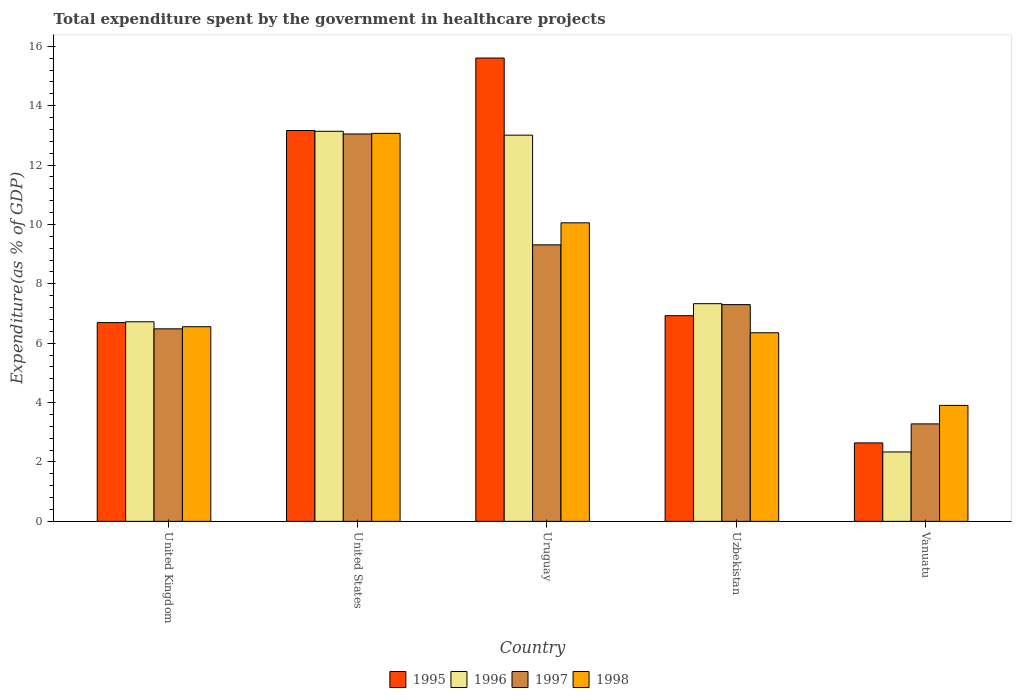How many different coloured bars are there?
Give a very brief answer. 4. How many groups of bars are there?
Give a very brief answer. 5. Are the number of bars on each tick of the X-axis equal?
Your answer should be compact. Yes. How many bars are there on the 5th tick from the left?
Offer a very short reply. 4. How many bars are there on the 2nd tick from the right?
Keep it short and to the point. 4. What is the label of the 1st group of bars from the left?
Offer a very short reply. United Kingdom. In how many cases, is the number of bars for a given country not equal to the number of legend labels?
Your answer should be compact. 0. What is the total expenditure spent by the government in healthcare projects in 1998 in Vanuatu?
Provide a short and direct response. 3.91. Across all countries, what is the maximum total expenditure spent by the government in healthcare projects in 1995?
Offer a very short reply. 15.6. Across all countries, what is the minimum total expenditure spent by the government in healthcare projects in 1998?
Your answer should be compact. 3.91. In which country was the total expenditure spent by the government in healthcare projects in 1996 minimum?
Offer a very short reply. Vanuatu. What is the total total expenditure spent by the government in healthcare projects in 1998 in the graph?
Provide a short and direct response. 39.93. What is the difference between the total expenditure spent by the government in healthcare projects in 1996 in Uruguay and that in Uzbekistan?
Provide a short and direct response. 5.68. What is the difference between the total expenditure spent by the government in healthcare projects in 1997 in Vanuatu and the total expenditure spent by the government in healthcare projects in 1995 in Uzbekistan?
Your answer should be very brief. -3.64. What is the average total expenditure spent by the government in healthcare projects in 1997 per country?
Your answer should be compact. 7.88. What is the difference between the total expenditure spent by the government in healthcare projects of/in 1997 and total expenditure spent by the government in healthcare projects of/in 1996 in Vanuatu?
Offer a very short reply. 0.95. What is the ratio of the total expenditure spent by the government in healthcare projects in 1997 in United States to that in Uzbekistan?
Your response must be concise. 1.79. What is the difference between the highest and the second highest total expenditure spent by the government in healthcare projects in 1996?
Give a very brief answer. -0.13. What is the difference between the highest and the lowest total expenditure spent by the government in healthcare projects in 1997?
Provide a succinct answer. 9.76. In how many countries, is the total expenditure spent by the government in healthcare projects in 1995 greater than the average total expenditure spent by the government in healthcare projects in 1995 taken over all countries?
Offer a terse response. 2. Is the sum of the total expenditure spent by the government in healthcare projects in 1997 in United States and Vanuatu greater than the maximum total expenditure spent by the government in healthcare projects in 1995 across all countries?
Ensure brevity in your answer.  Yes. What does the 3rd bar from the left in United Kingdom represents?
Offer a terse response. 1997. Is it the case that in every country, the sum of the total expenditure spent by the government in healthcare projects in 1998 and total expenditure spent by the government in healthcare projects in 1995 is greater than the total expenditure spent by the government in healthcare projects in 1997?
Your answer should be compact. Yes. How many bars are there?
Give a very brief answer. 20. Are all the bars in the graph horizontal?
Keep it short and to the point. No. What is the difference between two consecutive major ticks on the Y-axis?
Give a very brief answer. 2. Are the values on the major ticks of Y-axis written in scientific E-notation?
Offer a terse response. No. Does the graph contain any zero values?
Ensure brevity in your answer.  No. Does the graph contain grids?
Give a very brief answer. No. Where does the legend appear in the graph?
Make the answer very short. Bottom center. What is the title of the graph?
Offer a terse response. Total expenditure spent by the government in healthcare projects. What is the label or title of the X-axis?
Make the answer very short. Country. What is the label or title of the Y-axis?
Your answer should be compact. Expenditure(as % of GDP). What is the Expenditure(as % of GDP) in 1995 in United Kingdom?
Your answer should be very brief. 6.69. What is the Expenditure(as % of GDP) in 1996 in United Kingdom?
Keep it short and to the point. 6.72. What is the Expenditure(as % of GDP) of 1997 in United Kingdom?
Make the answer very short. 6.48. What is the Expenditure(as % of GDP) in 1998 in United Kingdom?
Ensure brevity in your answer.  6.56. What is the Expenditure(as % of GDP) in 1995 in United States?
Your answer should be very brief. 13.16. What is the Expenditure(as % of GDP) of 1996 in United States?
Ensure brevity in your answer.  13.14. What is the Expenditure(as % of GDP) in 1997 in United States?
Your response must be concise. 13.05. What is the Expenditure(as % of GDP) of 1998 in United States?
Provide a short and direct response. 13.07. What is the Expenditure(as % of GDP) in 1995 in Uruguay?
Make the answer very short. 15.6. What is the Expenditure(as % of GDP) of 1996 in Uruguay?
Your answer should be very brief. 13.01. What is the Expenditure(as % of GDP) in 1997 in Uruguay?
Make the answer very short. 9.31. What is the Expenditure(as % of GDP) of 1998 in Uruguay?
Offer a very short reply. 10.05. What is the Expenditure(as % of GDP) in 1995 in Uzbekistan?
Provide a short and direct response. 6.93. What is the Expenditure(as % of GDP) of 1996 in Uzbekistan?
Provide a succinct answer. 7.33. What is the Expenditure(as % of GDP) in 1997 in Uzbekistan?
Offer a very short reply. 7.3. What is the Expenditure(as % of GDP) of 1998 in Uzbekistan?
Keep it short and to the point. 6.35. What is the Expenditure(as % of GDP) in 1995 in Vanuatu?
Provide a short and direct response. 2.64. What is the Expenditure(as % of GDP) of 1996 in Vanuatu?
Make the answer very short. 2.34. What is the Expenditure(as % of GDP) of 1997 in Vanuatu?
Your answer should be compact. 3.28. What is the Expenditure(as % of GDP) of 1998 in Vanuatu?
Give a very brief answer. 3.91. Across all countries, what is the maximum Expenditure(as % of GDP) in 1995?
Keep it short and to the point. 15.6. Across all countries, what is the maximum Expenditure(as % of GDP) in 1996?
Provide a succinct answer. 13.14. Across all countries, what is the maximum Expenditure(as % of GDP) of 1997?
Give a very brief answer. 13.05. Across all countries, what is the maximum Expenditure(as % of GDP) of 1998?
Ensure brevity in your answer.  13.07. Across all countries, what is the minimum Expenditure(as % of GDP) of 1995?
Your answer should be very brief. 2.64. Across all countries, what is the minimum Expenditure(as % of GDP) in 1996?
Ensure brevity in your answer.  2.34. Across all countries, what is the minimum Expenditure(as % of GDP) of 1997?
Offer a very short reply. 3.28. Across all countries, what is the minimum Expenditure(as % of GDP) in 1998?
Provide a succinct answer. 3.91. What is the total Expenditure(as % of GDP) in 1995 in the graph?
Make the answer very short. 45.03. What is the total Expenditure(as % of GDP) in 1996 in the graph?
Your answer should be very brief. 42.53. What is the total Expenditure(as % of GDP) of 1997 in the graph?
Keep it short and to the point. 39.42. What is the total Expenditure(as % of GDP) of 1998 in the graph?
Provide a short and direct response. 39.93. What is the difference between the Expenditure(as % of GDP) of 1995 in United Kingdom and that in United States?
Provide a succinct answer. -6.47. What is the difference between the Expenditure(as % of GDP) in 1996 in United Kingdom and that in United States?
Offer a terse response. -6.41. What is the difference between the Expenditure(as % of GDP) in 1997 in United Kingdom and that in United States?
Keep it short and to the point. -6.56. What is the difference between the Expenditure(as % of GDP) of 1998 in United Kingdom and that in United States?
Ensure brevity in your answer.  -6.51. What is the difference between the Expenditure(as % of GDP) in 1995 in United Kingdom and that in Uruguay?
Offer a terse response. -8.91. What is the difference between the Expenditure(as % of GDP) in 1996 in United Kingdom and that in Uruguay?
Keep it short and to the point. -6.28. What is the difference between the Expenditure(as % of GDP) of 1997 in United Kingdom and that in Uruguay?
Provide a succinct answer. -2.83. What is the difference between the Expenditure(as % of GDP) of 1998 in United Kingdom and that in Uruguay?
Provide a short and direct response. -3.5. What is the difference between the Expenditure(as % of GDP) in 1995 in United Kingdom and that in Uzbekistan?
Ensure brevity in your answer.  -0.23. What is the difference between the Expenditure(as % of GDP) in 1996 in United Kingdom and that in Uzbekistan?
Offer a terse response. -0.61. What is the difference between the Expenditure(as % of GDP) in 1997 in United Kingdom and that in Uzbekistan?
Make the answer very short. -0.81. What is the difference between the Expenditure(as % of GDP) of 1998 in United Kingdom and that in Uzbekistan?
Provide a short and direct response. 0.2. What is the difference between the Expenditure(as % of GDP) of 1995 in United Kingdom and that in Vanuatu?
Make the answer very short. 4.05. What is the difference between the Expenditure(as % of GDP) in 1996 in United Kingdom and that in Vanuatu?
Your answer should be very brief. 4.38. What is the difference between the Expenditure(as % of GDP) in 1997 in United Kingdom and that in Vanuatu?
Offer a terse response. 3.2. What is the difference between the Expenditure(as % of GDP) of 1998 in United Kingdom and that in Vanuatu?
Keep it short and to the point. 2.65. What is the difference between the Expenditure(as % of GDP) of 1995 in United States and that in Uruguay?
Provide a succinct answer. -2.44. What is the difference between the Expenditure(as % of GDP) in 1996 in United States and that in Uruguay?
Make the answer very short. 0.13. What is the difference between the Expenditure(as % of GDP) of 1997 in United States and that in Uruguay?
Your answer should be compact. 3.73. What is the difference between the Expenditure(as % of GDP) of 1998 in United States and that in Uruguay?
Give a very brief answer. 3.01. What is the difference between the Expenditure(as % of GDP) of 1995 in United States and that in Uzbekistan?
Keep it short and to the point. 6.24. What is the difference between the Expenditure(as % of GDP) of 1996 in United States and that in Uzbekistan?
Give a very brief answer. 5.81. What is the difference between the Expenditure(as % of GDP) in 1997 in United States and that in Uzbekistan?
Offer a terse response. 5.75. What is the difference between the Expenditure(as % of GDP) in 1998 in United States and that in Uzbekistan?
Keep it short and to the point. 6.72. What is the difference between the Expenditure(as % of GDP) of 1995 in United States and that in Vanuatu?
Your response must be concise. 10.52. What is the difference between the Expenditure(as % of GDP) in 1996 in United States and that in Vanuatu?
Ensure brevity in your answer.  10.8. What is the difference between the Expenditure(as % of GDP) of 1997 in United States and that in Vanuatu?
Provide a short and direct response. 9.76. What is the difference between the Expenditure(as % of GDP) in 1998 in United States and that in Vanuatu?
Provide a short and direct response. 9.16. What is the difference between the Expenditure(as % of GDP) of 1995 in Uruguay and that in Uzbekistan?
Your answer should be compact. 8.68. What is the difference between the Expenditure(as % of GDP) of 1996 in Uruguay and that in Uzbekistan?
Provide a succinct answer. 5.68. What is the difference between the Expenditure(as % of GDP) in 1997 in Uruguay and that in Uzbekistan?
Keep it short and to the point. 2.01. What is the difference between the Expenditure(as % of GDP) of 1998 in Uruguay and that in Uzbekistan?
Your answer should be very brief. 3.7. What is the difference between the Expenditure(as % of GDP) of 1995 in Uruguay and that in Vanuatu?
Your response must be concise. 12.96. What is the difference between the Expenditure(as % of GDP) of 1996 in Uruguay and that in Vanuatu?
Offer a very short reply. 10.67. What is the difference between the Expenditure(as % of GDP) of 1997 in Uruguay and that in Vanuatu?
Your answer should be compact. 6.03. What is the difference between the Expenditure(as % of GDP) of 1998 in Uruguay and that in Vanuatu?
Provide a short and direct response. 6.15. What is the difference between the Expenditure(as % of GDP) in 1995 in Uzbekistan and that in Vanuatu?
Give a very brief answer. 4.28. What is the difference between the Expenditure(as % of GDP) in 1996 in Uzbekistan and that in Vanuatu?
Make the answer very short. 4.99. What is the difference between the Expenditure(as % of GDP) of 1997 in Uzbekistan and that in Vanuatu?
Ensure brevity in your answer.  4.02. What is the difference between the Expenditure(as % of GDP) in 1998 in Uzbekistan and that in Vanuatu?
Keep it short and to the point. 2.45. What is the difference between the Expenditure(as % of GDP) in 1995 in United Kingdom and the Expenditure(as % of GDP) in 1996 in United States?
Ensure brevity in your answer.  -6.44. What is the difference between the Expenditure(as % of GDP) in 1995 in United Kingdom and the Expenditure(as % of GDP) in 1997 in United States?
Make the answer very short. -6.35. What is the difference between the Expenditure(as % of GDP) of 1995 in United Kingdom and the Expenditure(as % of GDP) of 1998 in United States?
Give a very brief answer. -6.37. What is the difference between the Expenditure(as % of GDP) in 1996 in United Kingdom and the Expenditure(as % of GDP) in 1997 in United States?
Provide a short and direct response. -6.32. What is the difference between the Expenditure(as % of GDP) in 1996 in United Kingdom and the Expenditure(as % of GDP) in 1998 in United States?
Offer a very short reply. -6.34. What is the difference between the Expenditure(as % of GDP) in 1997 in United Kingdom and the Expenditure(as % of GDP) in 1998 in United States?
Ensure brevity in your answer.  -6.58. What is the difference between the Expenditure(as % of GDP) in 1995 in United Kingdom and the Expenditure(as % of GDP) in 1996 in Uruguay?
Keep it short and to the point. -6.31. What is the difference between the Expenditure(as % of GDP) of 1995 in United Kingdom and the Expenditure(as % of GDP) of 1997 in Uruguay?
Offer a terse response. -2.62. What is the difference between the Expenditure(as % of GDP) of 1995 in United Kingdom and the Expenditure(as % of GDP) of 1998 in Uruguay?
Your answer should be very brief. -3.36. What is the difference between the Expenditure(as % of GDP) of 1996 in United Kingdom and the Expenditure(as % of GDP) of 1997 in Uruguay?
Your answer should be compact. -2.59. What is the difference between the Expenditure(as % of GDP) of 1996 in United Kingdom and the Expenditure(as % of GDP) of 1998 in Uruguay?
Keep it short and to the point. -3.33. What is the difference between the Expenditure(as % of GDP) in 1997 in United Kingdom and the Expenditure(as % of GDP) in 1998 in Uruguay?
Provide a succinct answer. -3.57. What is the difference between the Expenditure(as % of GDP) in 1995 in United Kingdom and the Expenditure(as % of GDP) in 1996 in Uzbekistan?
Your answer should be very brief. -0.64. What is the difference between the Expenditure(as % of GDP) of 1995 in United Kingdom and the Expenditure(as % of GDP) of 1997 in Uzbekistan?
Offer a terse response. -0.6. What is the difference between the Expenditure(as % of GDP) of 1995 in United Kingdom and the Expenditure(as % of GDP) of 1998 in Uzbekistan?
Your response must be concise. 0.34. What is the difference between the Expenditure(as % of GDP) in 1996 in United Kingdom and the Expenditure(as % of GDP) in 1997 in Uzbekistan?
Your answer should be compact. -0.58. What is the difference between the Expenditure(as % of GDP) of 1996 in United Kingdom and the Expenditure(as % of GDP) of 1998 in Uzbekistan?
Your response must be concise. 0.37. What is the difference between the Expenditure(as % of GDP) of 1997 in United Kingdom and the Expenditure(as % of GDP) of 1998 in Uzbekistan?
Your response must be concise. 0.13. What is the difference between the Expenditure(as % of GDP) in 1995 in United Kingdom and the Expenditure(as % of GDP) in 1996 in Vanuatu?
Ensure brevity in your answer.  4.36. What is the difference between the Expenditure(as % of GDP) in 1995 in United Kingdom and the Expenditure(as % of GDP) in 1997 in Vanuatu?
Provide a short and direct response. 3.41. What is the difference between the Expenditure(as % of GDP) in 1995 in United Kingdom and the Expenditure(as % of GDP) in 1998 in Vanuatu?
Your answer should be compact. 2.79. What is the difference between the Expenditure(as % of GDP) of 1996 in United Kingdom and the Expenditure(as % of GDP) of 1997 in Vanuatu?
Give a very brief answer. 3.44. What is the difference between the Expenditure(as % of GDP) of 1996 in United Kingdom and the Expenditure(as % of GDP) of 1998 in Vanuatu?
Provide a succinct answer. 2.82. What is the difference between the Expenditure(as % of GDP) in 1997 in United Kingdom and the Expenditure(as % of GDP) in 1998 in Vanuatu?
Provide a succinct answer. 2.58. What is the difference between the Expenditure(as % of GDP) in 1995 in United States and the Expenditure(as % of GDP) in 1996 in Uruguay?
Provide a succinct answer. 0.16. What is the difference between the Expenditure(as % of GDP) of 1995 in United States and the Expenditure(as % of GDP) of 1997 in Uruguay?
Your answer should be very brief. 3.85. What is the difference between the Expenditure(as % of GDP) in 1995 in United States and the Expenditure(as % of GDP) in 1998 in Uruguay?
Your answer should be compact. 3.11. What is the difference between the Expenditure(as % of GDP) in 1996 in United States and the Expenditure(as % of GDP) in 1997 in Uruguay?
Ensure brevity in your answer.  3.83. What is the difference between the Expenditure(as % of GDP) in 1996 in United States and the Expenditure(as % of GDP) in 1998 in Uruguay?
Offer a very short reply. 3.08. What is the difference between the Expenditure(as % of GDP) of 1997 in United States and the Expenditure(as % of GDP) of 1998 in Uruguay?
Make the answer very short. 2.99. What is the difference between the Expenditure(as % of GDP) in 1995 in United States and the Expenditure(as % of GDP) in 1996 in Uzbekistan?
Offer a terse response. 5.83. What is the difference between the Expenditure(as % of GDP) in 1995 in United States and the Expenditure(as % of GDP) in 1997 in Uzbekistan?
Make the answer very short. 5.86. What is the difference between the Expenditure(as % of GDP) in 1995 in United States and the Expenditure(as % of GDP) in 1998 in Uzbekistan?
Your answer should be compact. 6.81. What is the difference between the Expenditure(as % of GDP) of 1996 in United States and the Expenditure(as % of GDP) of 1997 in Uzbekistan?
Make the answer very short. 5.84. What is the difference between the Expenditure(as % of GDP) of 1996 in United States and the Expenditure(as % of GDP) of 1998 in Uzbekistan?
Provide a succinct answer. 6.79. What is the difference between the Expenditure(as % of GDP) in 1997 in United States and the Expenditure(as % of GDP) in 1998 in Uzbekistan?
Make the answer very short. 6.7. What is the difference between the Expenditure(as % of GDP) in 1995 in United States and the Expenditure(as % of GDP) in 1996 in Vanuatu?
Offer a terse response. 10.82. What is the difference between the Expenditure(as % of GDP) of 1995 in United States and the Expenditure(as % of GDP) of 1997 in Vanuatu?
Keep it short and to the point. 9.88. What is the difference between the Expenditure(as % of GDP) of 1995 in United States and the Expenditure(as % of GDP) of 1998 in Vanuatu?
Offer a very short reply. 9.26. What is the difference between the Expenditure(as % of GDP) in 1996 in United States and the Expenditure(as % of GDP) in 1997 in Vanuatu?
Your answer should be compact. 9.85. What is the difference between the Expenditure(as % of GDP) in 1996 in United States and the Expenditure(as % of GDP) in 1998 in Vanuatu?
Provide a succinct answer. 9.23. What is the difference between the Expenditure(as % of GDP) in 1997 in United States and the Expenditure(as % of GDP) in 1998 in Vanuatu?
Keep it short and to the point. 9.14. What is the difference between the Expenditure(as % of GDP) of 1995 in Uruguay and the Expenditure(as % of GDP) of 1996 in Uzbekistan?
Give a very brief answer. 8.27. What is the difference between the Expenditure(as % of GDP) of 1995 in Uruguay and the Expenditure(as % of GDP) of 1997 in Uzbekistan?
Your response must be concise. 8.3. What is the difference between the Expenditure(as % of GDP) of 1995 in Uruguay and the Expenditure(as % of GDP) of 1998 in Uzbekistan?
Give a very brief answer. 9.25. What is the difference between the Expenditure(as % of GDP) of 1996 in Uruguay and the Expenditure(as % of GDP) of 1997 in Uzbekistan?
Provide a short and direct response. 5.71. What is the difference between the Expenditure(as % of GDP) of 1996 in Uruguay and the Expenditure(as % of GDP) of 1998 in Uzbekistan?
Provide a succinct answer. 6.66. What is the difference between the Expenditure(as % of GDP) of 1997 in Uruguay and the Expenditure(as % of GDP) of 1998 in Uzbekistan?
Give a very brief answer. 2.96. What is the difference between the Expenditure(as % of GDP) of 1995 in Uruguay and the Expenditure(as % of GDP) of 1996 in Vanuatu?
Ensure brevity in your answer.  13.27. What is the difference between the Expenditure(as % of GDP) of 1995 in Uruguay and the Expenditure(as % of GDP) of 1997 in Vanuatu?
Offer a very short reply. 12.32. What is the difference between the Expenditure(as % of GDP) in 1995 in Uruguay and the Expenditure(as % of GDP) in 1998 in Vanuatu?
Your answer should be very brief. 11.7. What is the difference between the Expenditure(as % of GDP) of 1996 in Uruguay and the Expenditure(as % of GDP) of 1997 in Vanuatu?
Provide a succinct answer. 9.72. What is the difference between the Expenditure(as % of GDP) in 1996 in Uruguay and the Expenditure(as % of GDP) in 1998 in Vanuatu?
Ensure brevity in your answer.  9.1. What is the difference between the Expenditure(as % of GDP) in 1997 in Uruguay and the Expenditure(as % of GDP) in 1998 in Vanuatu?
Provide a short and direct response. 5.41. What is the difference between the Expenditure(as % of GDP) of 1995 in Uzbekistan and the Expenditure(as % of GDP) of 1996 in Vanuatu?
Your response must be concise. 4.59. What is the difference between the Expenditure(as % of GDP) in 1995 in Uzbekistan and the Expenditure(as % of GDP) in 1997 in Vanuatu?
Your answer should be very brief. 3.64. What is the difference between the Expenditure(as % of GDP) of 1995 in Uzbekistan and the Expenditure(as % of GDP) of 1998 in Vanuatu?
Provide a succinct answer. 3.02. What is the difference between the Expenditure(as % of GDP) in 1996 in Uzbekistan and the Expenditure(as % of GDP) in 1997 in Vanuatu?
Offer a terse response. 4.05. What is the difference between the Expenditure(as % of GDP) in 1996 in Uzbekistan and the Expenditure(as % of GDP) in 1998 in Vanuatu?
Provide a short and direct response. 3.43. What is the difference between the Expenditure(as % of GDP) in 1997 in Uzbekistan and the Expenditure(as % of GDP) in 1998 in Vanuatu?
Make the answer very short. 3.39. What is the average Expenditure(as % of GDP) in 1995 per country?
Provide a short and direct response. 9.01. What is the average Expenditure(as % of GDP) in 1996 per country?
Offer a very short reply. 8.51. What is the average Expenditure(as % of GDP) in 1997 per country?
Ensure brevity in your answer.  7.88. What is the average Expenditure(as % of GDP) in 1998 per country?
Make the answer very short. 7.99. What is the difference between the Expenditure(as % of GDP) of 1995 and Expenditure(as % of GDP) of 1996 in United Kingdom?
Provide a succinct answer. -0.03. What is the difference between the Expenditure(as % of GDP) in 1995 and Expenditure(as % of GDP) in 1997 in United Kingdom?
Provide a short and direct response. 0.21. What is the difference between the Expenditure(as % of GDP) of 1995 and Expenditure(as % of GDP) of 1998 in United Kingdom?
Your answer should be compact. 0.14. What is the difference between the Expenditure(as % of GDP) in 1996 and Expenditure(as % of GDP) in 1997 in United Kingdom?
Provide a succinct answer. 0.24. What is the difference between the Expenditure(as % of GDP) in 1996 and Expenditure(as % of GDP) in 1998 in United Kingdom?
Ensure brevity in your answer.  0.17. What is the difference between the Expenditure(as % of GDP) of 1997 and Expenditure(as % of GDP) of 1998 in United Kingdom?
Offer a very short reply. -0.07. What is the difference between the Expenditure(as % of GDP) of 1995 and Expenditure(as % of GDP) of 1996 in United States?
Give a very brief answer. 0.03. What is the difference between the Expenditure(as % of GDP) in 1995 and Expenditure(as % of GDP) in 1997 in United States?
Your answer should be very brief. 0.12. What is the difference between the Expenditure(as % of GDP) of 1995 and Expenditure(as % of GDP) of 1998 in United States?
Offer a terse response. 0.1. What is the difference between the Expenditure(as % of GDP) in 1996 and Expenditure(as % of GDP) in 1997 in United States?
Provide a short and direct response. 0.09. What is the difference between the Expenditure(as % of GDP) of 1996 and Expenditure(as % of GDP) of 1998 in United States?
Keep it short and to the point. 0.07. What is the difference between the Expenditure(as % of GDP) in 1997 and Expenditure(as % of GDP) in 1998 in United States?
Your answer should be very brief. -0.02. What is the difference between the Expenditure(as % of GDP) in 1995 and Expenditure(as % of GDP) in 1996 in Uruguay?
Ensure brevity in your answer.  2.6. What is the difference between the Expenditure(as % of GDP) of 1995 and Expenditure(as % of GDP) of 1997 in Uruguay?
Offer a very short reply. 6.29. What is the difference between the Expenditure(as % of GDP) of 1995 and Expenditure(as % of GDP) of 1998 in Uruguay?
Provide a short and direct response. 5.55. What is the difference between the Expenditure(as % of GDP) in 1996 and Expenditure(as % of GDP) in 1997 in Uruguay?
Provide a succinct answer. 3.69. What is the difference between the Expenditure(as % of GDP) in 1996 and Expenditure(as % of GDP) in 1998 in Uruguay?
Make the answer very short. 2.95. What is the difference between the Expenditure(as % of GDP) in 1997 and Expenditure(as % of GDP) in 1998 in Uruguay?
Provide a short and direct response. -0.74. What is the difference between the Expenditure(as % of GDP) in 1995 and Expenditure(as % of GDP) in 1996 in Uzbekistan?
Ensure brevity in your answer.  -0.4. What is the difference between the Expenditure(as % of GDP) in 1995 and Expenditure(as % of GDP) in 1997 in Uzbekistan?
Give a very brief answer. -0.37. What is the difference between the Expenditure(as % of GDP) of 1995 and Expenditure(as % of GDP) of 1998 in Uzbekistan?
Ensure brevity in your answer.  0.58. What is the difference between the Expenditure(as % of GDP) of 1996 and Expenditure(as % of GDP) of 1997 in Uzbekistan?
Your answer should be very brief. 0.03. What is the difference between the Expenditure(as % of GDP) of 1996 and Expenditure(as % of GDP) of 1998 in Uzbekistan?
Your response must be concise. 0.98. What is the difference between the Expenditure(as % of GDP) in 1997 and Expenditure(as % of GDP) in 1998 in Uzbekistan?
Give a very brief answer. 0.95. What is the difference between the Expenditure(as % of GDP) in 1995 and Expenditure(as % of GDP) in 1996 in Vanuatu?
Your answer should be compact. 0.3. What is the difference between the Expenditure(as % of GDP) of 1995 and Expenditure(as % of GDP) of 1997 in Vanuatu?
Ensure brevity in your answer.  -0.64. What is the difference between the Expenditure(as % of GDP) in 1995 and Expenditure(as % of GDP) in 1998 in Vanuatu?
Keep it short and to the point. -1.26. What is the difference between the Expenditure(as % of GDP) of 1996 and Expenditure(as % of GDP) of 1997 in Vanuatu?
Your answer should be very brief. -0.94. What is the difference between the Expenditure(as % of GDP) of 1996 and Expenditure(as % of GDP) of 1998 in Vanuatu?
Your answer should be very brief. -1.57. What is the difference between the Expenditure(as % of GDP) of 1997 and Expenditure(as % of GDP) of 1998 in Vanuatu?
Keep it short and to the point. -0.62. What is the ratio of the Expenditure(as % of GDP) of 1995 in United Kingdom to that in United States?
Ensure brevity in your answer.  0.51. What is the ratio of the Expenditure(as % of GDP) of 1996 in United Kingdom to that in United States?
Offer a very short reply. 0.51. What is the ratio of the Expenditure(as % of GDP) of 1997 in United Kingdom to that in United States?
Provide a short and direct response. 0.5. What is the ratio of the Expenditure(as % of GDP) in 1998 in United Kingdom to that in United States?
Your answer should be very brief. 0.5. What is the ratio of the Expenditure(as % of GDP) of 1995 in United Kingdom to that in Uruguay?
Provide a succinct answer. 0.43. What is the ratio of the Expenditure(as % of GDP) of 1996 in United Kingdom to that in Uruguay?
Offer a terse response. 0.52. What is the ratio of the Expenditure(as % of GDP) in 1997 in United Kingdom to that in Uruguay?
Offer a terse response. 0.7. What is the ratio of the Expenditure(as % of GDP) in 1998 in United Kingdom to that in Uruguay?
Your answer should be compact. 0.65. What is the ratio of the Expenditure(as % of GDP) in 1995 in United Kingdom to that in Uzbekistan?
Give a very brief answer. 0.97. What is the ratio of the Expenditure(as % of GDP) of 1996 in United Kingdom to that in Uzbekistan?
Your response must be concise. 0.92. What is the ratio of the Expenditure(as % of GDP) of 1997 in United Kingdom to that in Uzbekistan?
Offer a terse response. 0.89. What is the ratio of the Expenditure(as % of GDP) of 1998 in United Kingdom to that in Uzbekistan?
Your response must be concise. 1.03. What is the ratio of the Expenditure(as % of GDP) in 1995 in United Kingdom to that in Vanuatu?
Provide a succinct answer. 2.53. What is the ratio of the Expenditure(as % of GDP) of 1996 in United Kingdom to that in Vanuatu?
Make the answer very short. 2.88. What is the ratio of the Expenditure(as % of GDP) of 1997 in United Kingdom to that in Vanuatu?
Ensure brevity in your answer.  1.98. What is the ratio of the Expenditure(as % of GDP) of 1998 in United Kingdom to that in Vanuatu?
Offer a terse response. 1.68. What is the ratio of the Expenditure(as % of GDP) in 1995 in United States to that in Uruguay?
Your response must be concise. 0.84. What is the ratio of the Expenditure(as % of GDP) of 1996 in United States to that in Uruguay?
Offer a terse response. 1.01. What is the ratio of the Expenditure(as % of GDP) of 1997 in United States to that in Uruguay?
Give a very brief answer. 1.4. What is the ratio of the Expenditure(as % of GDP) of 1998 in United States to that in Uruguay?
Provide a short and direct response. 1.3. What is the ratio of the Expenditure(as % of GDP) of 1995 in United States to that in Uzbekistan?
Provide a short and direct response. 1.9. What is the ratio of the Expenditure(as % of GDP) of 1996 in United States to that in Uzbekistan?
Keep it short and to the point. 1.79. What is the ratio of the Expenditure(as % of GDP) of 1997 in United States to that in Uzbekistan?
Your response must be concise. 1.79. What is the ratio of the Expenditure(as % of GDP) of 1998 in United States to that in Uzbekistan?
Your response must be concise. 2.06. What is the ratio of the Expenditure(as % of GDP) in 1995 in United States to that in Vanuatu?
Your answer should be compact. 4.98. What is the ratio of the Expenditure(as % of GDP) in 1996 in United States to that in Vanuatu?
Keep it short and to the point. 5.62. What is the ratio of the Expenditure(as % of GDP) of 1997 in United States to that in Vanuatu?
Give a very brief answer. 3.97. What is the ratio of the Expenditure(as % of GDP) of 1998 in United States to that in Vanuatu?
Provide a short and direct response. 3.35. What is the ratio of the Expenditure(as % of GDP) in 1995 in Uruguay to that in Uzbekistan?
Keep it short and to the point. 2.25. What is the ratio of the Expenditure(as % of GDP) of 1996 in Uruguay to that in Uzbekistan?
Your answer should be very brief. 1.77. What is the ratio of the Expenditure(as % of GDP) of 1997 in Uruguay to that in Uzbekistan?
Your response must be concise. 1.28. What is the ratio of the Expenditure(as % of GDP) in 1998 in Uruguay to that in Uzbekistan?
Your answer should be very brief. 1.58. What is the ratio of the Expenditure(as % of GDP) in 1995 in Uruguay to that in Vanuatu?
Your answer should be very brief. 5.91. What is the ratio of the Expenditure(as % of GDP) of 1996 in Uruguay to that in Vanuatu?
Offer a terse response. 5.56. What is the ratio of the Expenditure(as % of GDP) in 1997 in Uruguay to that in Vanuatu?
Offer a terse response. 2.84. What is the ratio of the Expenditure(as % of GDP) in 1998 in Uruguay to that in Vanuatu?
Your answer should be very brief. 2.57. What is the ratio of the Expenditure(as % of GDP) in 1995 in Uzbekistan to that in Vanuatu?
Your answer should be compact. 2.62. What is the ratio of the Expenditure(as % of GDP) of 1996 in Uzbekistan to that in Vanuatu?
Provide a short and direct response. 3.14. What is the ratio of the Expenditure(as % of GDP) in 1997 in Uzbekistan to that in Vanuatu?
Offer a terse response. 2.22. What is the ratio of the Expenditure(as % of GDP) of 1998 in Uzbekistan to that in Vanuatu?
Provide a succinct answer. 1.63. What is the difference between the highest and the second highest Expenditure(as % of GDP) in 1995?
Offer a very short reply. 2.44. What is the difference between the highest and the second highest Expenditure(as % of GDP) in 1996?
Make the answer very short. 0.13. What is the difference between the highest and the second highest Expenditure(as % of GDP) of 1997?
Keep it short and to the point. 3.73. What is the difference between the highest and the second highest Expenditure(as % of GDP) of 1998?
Give a very brief answer. 3.01. What is the difference between the highest and the lowest Expenditure(as % of GDP) of 1995?
Keep it short and to the point. 12.96. What is the difference between the highest and the lowest Expenditure(as % of GDP) of 1996?
Offer a very short reply. 10.8. What is the difference between the highest and the lowest Expenditure(as % of GDP) of 1997?
Your answer should be very brief. 9.76. What is the difference between the highest and the lowest Expenditure(as % of GDP) of 1998?
Provide a succinct answer. 9.16. 